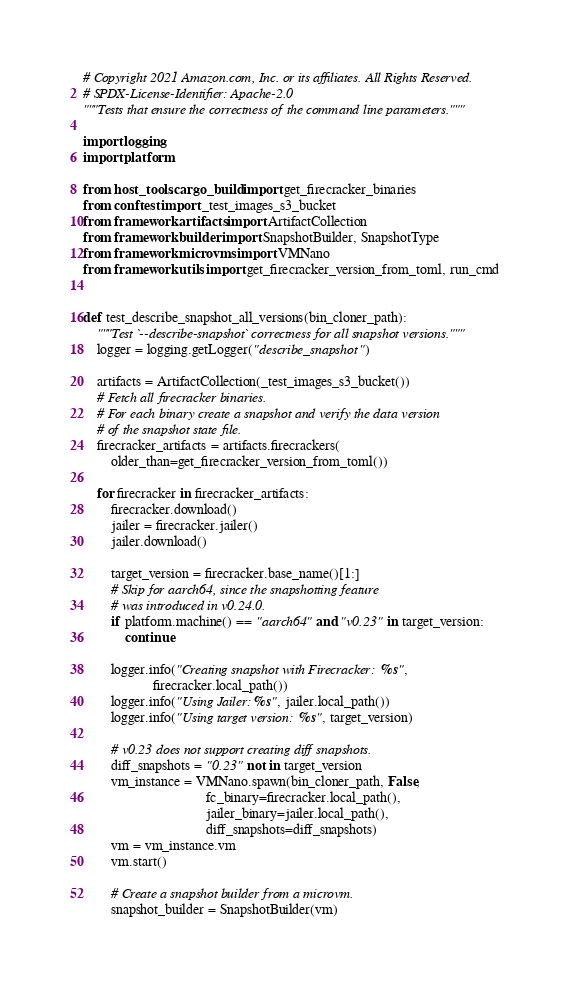<code> <loc_0><loc_0><loc_500><loc_500><_Python_># Copyright 2021 Amazon.com, Inc. or its affiliates. All Rights Reserved.
# SPDX-License-Identifier: Apache-2.0
"""Tests that ensure the correctness of the command line parameters."""

import logging
import platform

from host_tools.cargo_build import get_firecracker_binaries
from conftest import _test_images_s3_bucket
from framework.artifacts import ArtifactCollection
from framework.builder import SnapshotBuilder, SnapshotType
from framework.microvms import VMNano
from framework.utils import get_firecracker_version_from_toml, run_cmd


def test_describe_snapshot_all_versions(bin_cloner_path):
    """Test `--describe-snapshot` correctness for all snapshot versions."""
    logger = logging.getLogger("describe_snapshot")

    artifacts = ArtifactCollection(_test_images_s3_bucket())
    # Fetch all firecracker binaries.
    # For each binary create a snapshot and verify the data version
    # of the snapshot state file.
    firecracker_artifacts = artifacts.firecrackers(
        older_than=get_firecracker_version_from_toml())

    for firecracker in firecracker_artifacts:
        firecracker.download()
        jailer = firecracker.jailer()
        jailer.download()

        target_version = firecracker.base_name()[1:]
        # Skip for aarch64, since the snapshotting feature
        # was introduced in v0.24.0.
        if platform.machine() == "aarch64" and "v0.23" in target_version:
            continue

        logger.info("Creating snapshot with Firecracker: %s",
                    firecracker.local_path())
        logger.info("Using Jailer: %s", jailer.local_path())
        logger.info("Using target version: %s", target_version)

        # v0.23 does not support creating diff snapshots.
        diff_snapshots = "0.23" not in target_version
        vm_instance = VMNano.spawn(bin_cloner_path, False,
                                   fc_binary=firecracker.local_path(),
                                   jailer_binary=jailer.local_path(),
                                   diff_snapshots=diff_snapshots)
        vm = vm_instance.vm
        vm.start()

        # Create a snapshot builder from a microvm.
        snapshot_builder = SnapshotBuilder(vm)</code> 